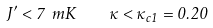<formula> <loc_0><loc_0><loc_500><loc_500>J ^ { \prime } < 7 \ m K \, \quad \kappa < \kappa _ { c 1 } = 0 . 2 0</formula> 